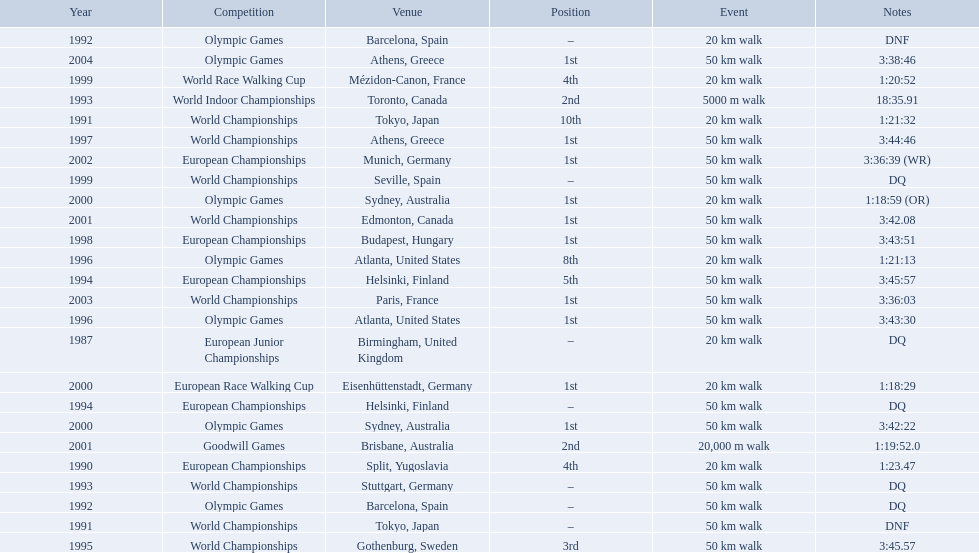What are the notes DQ, 1:23.47, 1:21:32, DNF, DNF, DQ, 18:35.91, DQ, DQ, 3:45:57, 3:45.57, 1:21:13, 3:43:30, 3:44:46, 3:43:51, 1:20:52, DQ, 1:18:29, 1:18:59 (OR), 3:42:22, 3:42.08, 1:19:52.0, 3:36:39 (WR), 3:36:03, 3:38:46. What time does the notes for 2004 show 3:38:46. 